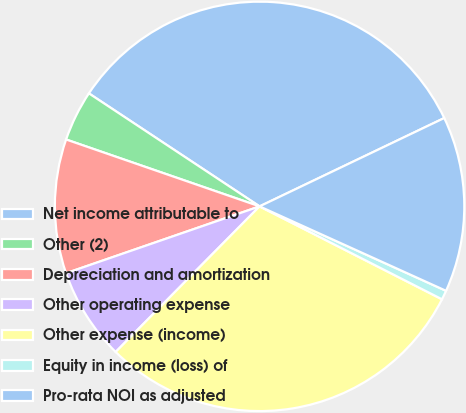<chart> <loc_0><loc_0><loc_500><loc_500><pie_chart><fcel>Net income attributable to<fcel>Other (2)<fcel>Depreciation and amortization<fcel>Other operating expense<fcel>Other expense (income)<fcel>Equity in income (loss) of<fcel>Pro-rata NOI as adjusted<nl><fcel>33.59%<fcel>4.01%<fcel>10.59%<fcel>7.3%<fcel>29.91%<fcel>0.73%<fcel>13.87%<nl></chart> 